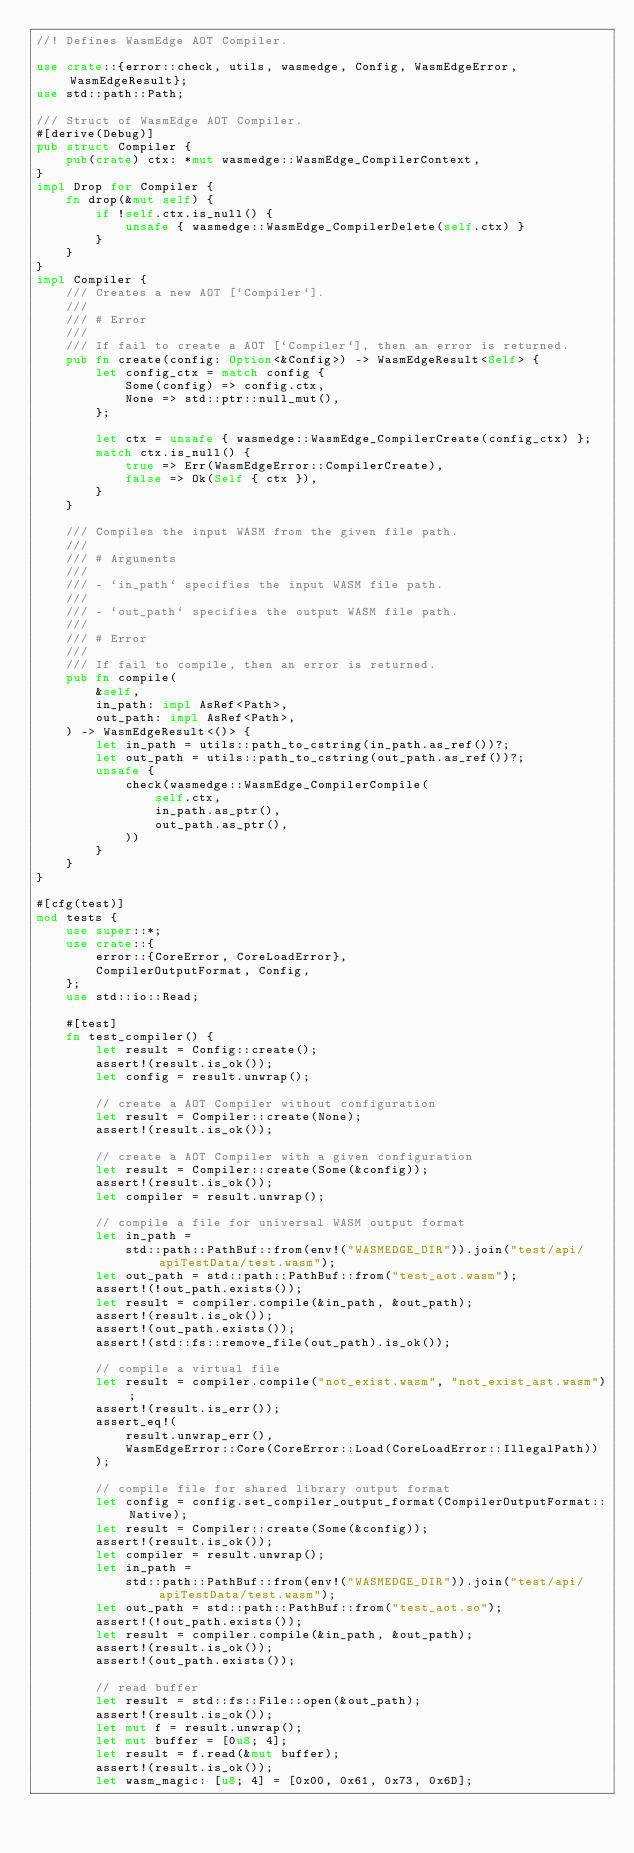<code> <loc_0><loc_0><loc_500><loc_500><_Rust_>//! Defines WasmEdge AOT Compiler.

use crate::{error::check, utils, wasmedge, Config, WasmEdgeError, WasmEdgeResult};
use std::path::Path;

/// Struct of WasmEdge AOT Compiler.
#[derive(Debug)]
pub struct Compiler {
    pub(crate) ctx: *mut wasmedge::WasmEdge_CompilerContext,
}
impl Drop for Compiler {
    fn drop(&mut self) {
        if !self.ctx.is_null() {
            unsafe { wasmedge::WasmEdge_CompilerDelete(self.ctx) }
        }
    }
}
impl Compiler {
    /// Creates a new AOT [`Compiler`].
    ///
    /// # Error
    ///
    /// If fail to create a AOT [`Compiler`], then an error is returned.
    pub fn create(config: Option<&Config>) -> WasmEdgeResult<Self> {
        let config_ctx = match config {
            Some(config) => config.ctx,
            None => std::ptr::null_mut(),
        };

        let ctx = unsafe { wasmedge::WasmEdge_CompilerCreate(config_ctx) };
        match ctx.is_null() {
            true => Err(WasmEdgeError::CompilerCreate),
            false => Ok(Self { ctx }),
        }
    }

    /// Compiles the input WASM from the given file path.
    ///
    /// # Arguments
    ///
    /// - `in_path` specifies the input WASM file path.
    ///
    /// - `out_path` specifies the output WASM file path.
    ///
    /// # Error
    ///
    /// If fail to compile, then an error is returned.
    pub fn compile(
        &self,
        in_path: impl AsRef<Path>,
        out_path: impl AsRef<Path>,
    ) -> WasmEdgeResult<()> {
        let in_path = utils::path_to_cstring(in_path.as_ref())?;
        let out_path = utils::path_to_cstring(out_path.as_ref())?;
        unsafe {
            check(wasmedge::WasmEdge_CompilerCompile(
                self.ctx,
                in_path.as_ptr(),
                out_path.as_ptr(),
            ))
        }
    }
}

#[cfg(test)]
mod tests {
    use super::*;
    use crate::{
        error::{CoreError, CoreLoadError},
        CompilerOutputFormat, Config,
    };
    use std::io::Read;

    #[test]
    fn test_compiler() {
        let result = Config::create();
        assert!(result.is_ok());
        let config = result.unwrap();

        // create a AOT Compiler without configuration
        let result = Compiler::create(None);
        assert!(result.is_ok());

        // create a AOT Compiler with a given configuration
        let result = Compiler::create(Some(&config));
        assert!(result.is_ok());
        let compiler = result.unwrap();

        // compile a file for universal WASM output format
        let in_path =
            std::path::PathBuf::from(env!("WASMEDGE_DIR")).join("test/api/apiTestData/test.wasm");
        let out_path = std::path::PathBuf::from("test_aot.wasm");
        assert!(!out_path.exists());
        let result = compiler.compile(&in_path, &out_path);
        assert!(result.is_ok());
        assert!(out_path.exists());
        assert!(std::fs::remove_file(out_path).is_ok());

        // compile a virtual file
        let result = compiler.compile("not_exist.wasm", "not_exist_ast.wasm");
        assert!(result.is_err());
        assert_eq!(
            result.unwrap_err(),
            WasmEdgeError::Core(CoreError::Load(CoreLoadError::IllegalPath))
        );

        // compile file for shared library output format
        let config = config.set_compiler_output_format(CompilerOutputFormat::Native);
        let result = Compiler::create(Some(&config));
        assert!(result.is_ok());
        let compiler = result.unwrap();
        let in_path =
            std::path::PathBuf::from(env!("WASMEDGE_DIR")).join("test/api/apiTestData/test.wasm");
        let out_path = std::path::PathBuf::from("test_aot.so");
        assert!(!out_path.exists());
        let result = compiler.compile(&in_path, &out_path);
        assert!(result.is_ok());
        assert!(out_path.exists());

        // read buffer
        let result = std::fs::File::open(&out_path);
        assert!(result.is_ok());
        let mut f = result.unwrap();
        let mut buffer = [0u8; 4];
        let result = f.read(&mut buffer);
        assert!(result.is_ok());
        let wasm_magic: [u8; 4] = [0x00, 0x61, 0x73, 0x6D];</code> 